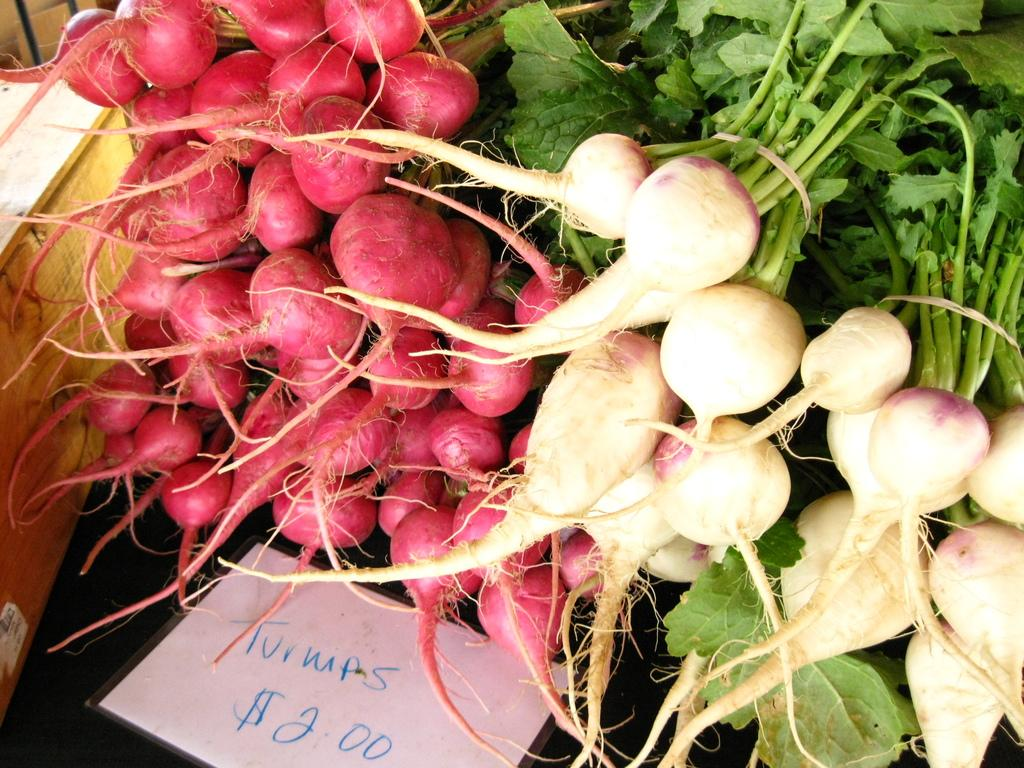What type of vegetables are present in the image? There are beetroots and radishes in the image. Can you describe the appearance of the beetroots? The beetroots appear to be round and have a reddish-purple color. How do the radishes look in the image? The radishes appear to be small and round, with a white or red color. What type of bead is used to decorate the radishes in the image? There are no beads present in the image, and the radishes are not decorated. 